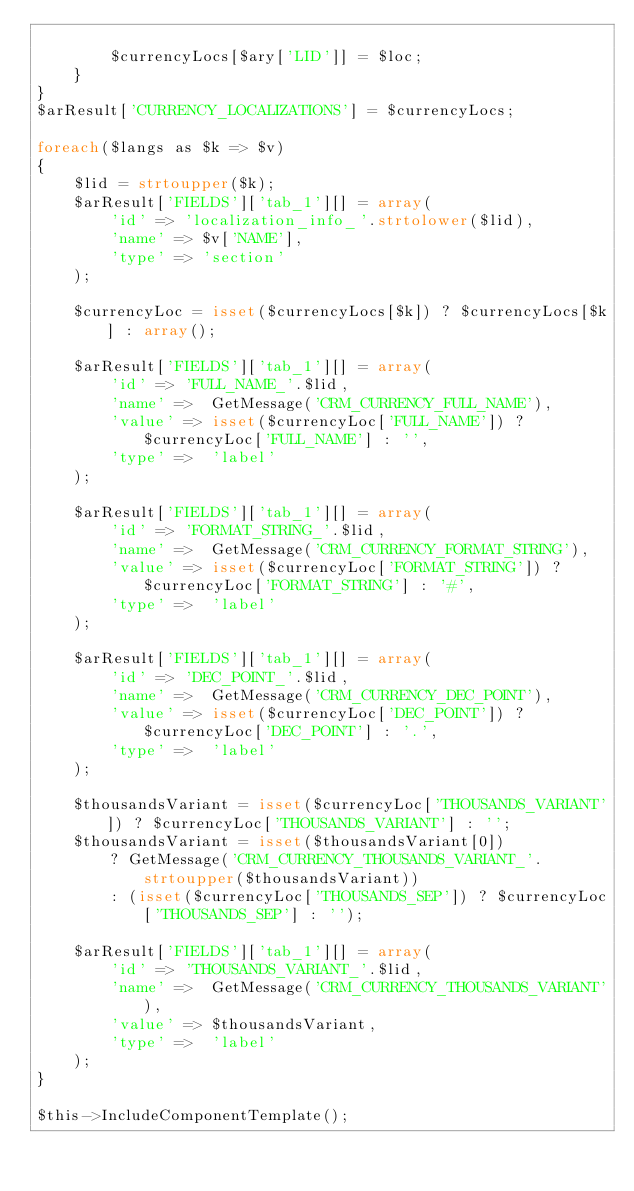<code> <loc_0><loc_0><loc_500><loc_500><_PHP_>
		$currencyLocs[$ary['LID']] = $loc;
	}
}
$arResult['CURRENCY_LOCALIZATIONS'] = $currencyLocs;

foreach($langs as $k => $v)
{
	$lid = strtoupper($k);
	$arResult['FIELDS']['tab_1'][] = array(
		'id' => 'localization_info_'.strtolower($lid),
		'name' => $v['NAME'],
		'type' => 'section'
	);

	$currencyLoc = isset($currencyLocs[$k]) ? $currencyLocs[$k] : array();

	$arResult['FIELDS']['tab_1'][] = array(
		'id' => 'FULL_NAME_'.$lid,
		'name' =>  GetMessage('CRM_CURRENCY_FULL_NAME'),
		'value' => isset($currencyLoc['FULL_NAME']) ? $currencyLoc['FULL_NAME'] : '',
		'type' =>  'label'
	);

	$arResult['FIELDS']['tab_1'][] = array(
		'id' => 'FORMAT_STRING_'.$lid,
		'name' =>  GetMessage('CRM_CURRENCY_FORMAT_STRING'),
		'value' => isset($currencyLoc['FORMAT_STRING']) ? $currencyLoc['FORMAT_STRING'] : '#',
		'type' =>  'label'
	);

	$arResult['FIELDS']['tab_1'][] = array(
		'id' => 'DEC_POINT_'.$lid,
		'name' =>  GetMessage('CRM_CURRENCY_DEC_POINT'),
		'value' => isset($currencyLoc['DEC_POINT']) ? $currencyLoc['DEC_POINT'] : '.',
		'type' =>  'label'
	);

	$thousandsVariant = isset($currencyLoc['THOUSANDS_VARIANT']) ? $currencyLoc['THOUSANDS_VARIANT'] : '';
	$thousandsVariant = isset($thousandsVariant[0])
		? GetMessage('CRM_CURRENCY_THOUSANDS_VARIANT_'.strtoupper($thousandsVariant))
		: (isset($currencyLoc['THOUSANDS_SEP']) ? $currencyLoc['THOUSANDS_SEP'] : '');

	$arResult['FIELDS']['tab_1'][] = array(
		'id' => 'THOUSANDS_VARIANT_'.$lid,
		'name' =>  GetMessage('CRM_CURRENCY_THOUSANDS_VARIANT'),
		'value' => $thousandsVariant,
		'type' =>  'label'
	);
}

$this->IncludeComponentTemplate();
</code> 